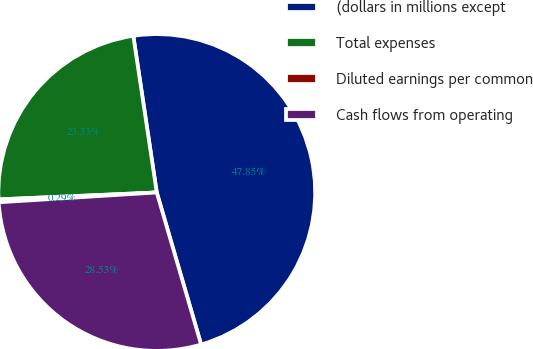Convert chart to OTSL. <chart><loc_0><loc_0><loc_500><loc_500><pie_chart><fcel>(dollars in millions except<fcel>Total expenses<fcel>Diluted earnings per common<fcel>Cash flows from operating<nl><fcel>47.85%<fcel>23.33%<fcel>0.29%<fcel>28.53%<nl></chart> 